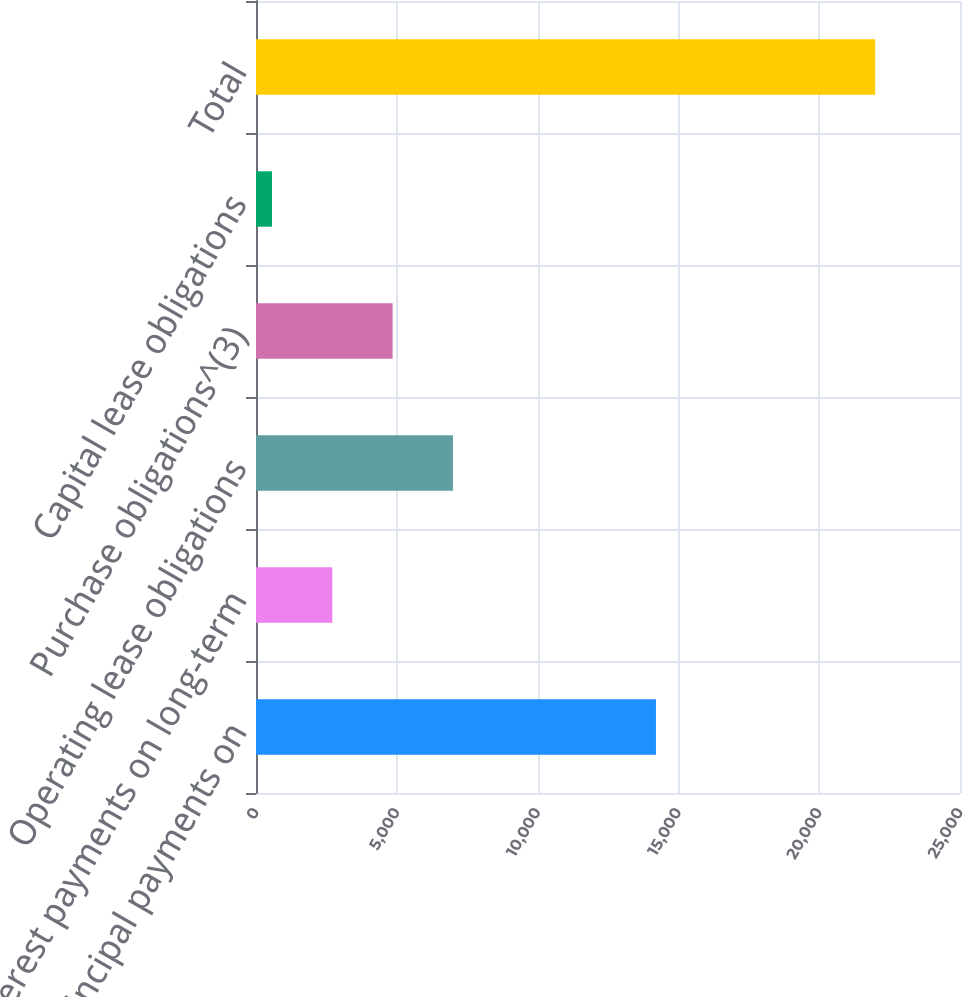<chart> <loc_0><loc_0><loc_500><loc_500><bar_chart><fcel>Principal payments on<fcel>Interest payments on long-term<fcel>Operating lease obligations<fcel>Purchase obligations^(3)<fcel>Capital lease obligations<fcel>Total<nl><fcel>14203<fcel>2710<fcel>6994<fcel>4852<fcel>568<fcel>21988<nl></chart> 